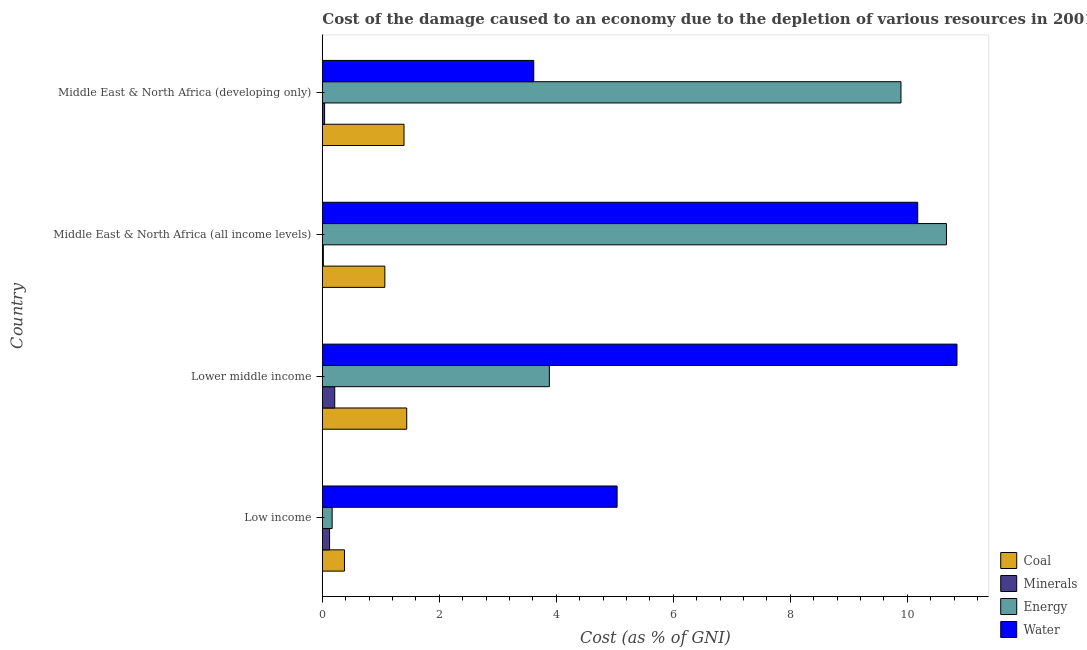How many different coloured bars are there?
Your answer should be very brief. 4. How many groups of bars are there?
Keep it short and to the point. 4. Are the number of bars per tick equal to the number of legend labels?
Provide a succinct answer. Yes. How many bars are there on the 4th tick from the bottom?
Offer a terse response. 4. What is the label of the 4th group of bars from the top?
Offer a terse response. Low income. What is the cost of damage due to depletion of energy in Lower middle income?
Keep it short and to the point. 3.88. Across all countries, what is the maximum cost of damage due to depletion of water?
Your response must be concise. 10.85. Across all countries, what is the minimum cost of damage due to depletion of minerals?
Provide a succinct answer. 0.02. In which country was the cost of damage due to depletion of minerals maximum?
Make the answer very short. Lower middle income. In which country was the cost of damage due to depletion of minerals minimum?
Provide a succinct answer. Middle East & North Africa (all income levels). What is the total cost of damage due to depletion of water in the graph?
Keep it short and to the point. 29.69. What is the difference between the cost of damage due to depletion of coal in Low income and that in Middle East & North Africa (all income levels)?
Your answer should be compact. -0.69. What is the difference between the cost of damage due to depletion of coal in Lower middle income and the cost of damage due to depletion of minerals in Low income?
Offer a very short reply. 1.32. What is the average cost of damage due to depletion of coal per country?
Ensure brevity in your answer.  1.07. What is the difference between the cost of damage due to depletion of minerals and cost of damage due to depletion of water in Middle East & North Africa (all income levels)?
Provide a short and direct response. -10.16. In how many countries, is the cost of damage due to depletion of minerals greater than 5.6 %?
Make the answer very short. 0. What is the ratio of the cost of damage due to depletion of coal in Middle East & North Africa (all income levels) to that in Middle East & North Africa (developing only)?
Offer a terse response. 0.77. Is the difference between the cost of damage due to depletion of coal in Middle East & North Africa (all income levels) and Middle East & North Africa (developing only) greater than the difference between the cost of damage due to depletion of energy in Middle East & North Africa (all income levels) and Middle East & North Africa (developing only)?
Provide a succinct answer. No. What is the difference between the highest and the second highest cost of damage due to depletion of water?
Provide a short and direct response. 0.67. What is the difference between the highest and the lowest cost of damage due to depletion of minerals?
Give a very brief answer. 0.19. In how many countries, is the cost of damage due to depletion of minerals greater than the average cost of damage due to depletion of minerals taken over all countries?
Provide a succinct answer. 2. Is it the case that in every country, the sum of the cost of damage due to depletion of water and cost of damage due to depletion of minerals is greater than the sum of cost of damage due to depletion of energy and cost of damage due to depletion of coal?
Keep it short and to the point. No. What does the 3rd bar from the top in Middle East & North Africa (developing only) represents?
Make the answer very short. Minerals. What does the 3rd bar from the bottom in Lower middle income represents?
Your answer should be very brief. Energy. How many bars are there?
Offer a very short reply. 16. Are all the bars in the graph horizontal?
Provide a succinct answer. Yes. How many countries are there in the graph?
Offer a very short reply. 4. Are the values on the major ticks of X-axis written in scientific E-notation?
Give a very brief answer. No. Does the graph contain any zero values?
Offer a terse response. No. Does the graph contain grids?
Give a very brief answer. No. What is the title of the graph?
Offer a terse response. Cost of the damage caused to an economy due to the depletion of various resources in 2001 . Does "Payroll services" appear as one of the legend labels in the graph?
Ensure brevity in your answer.  No. What is the label or title of the X-axis?
Your response must be concise. Cost (as % of GNI). What is the Cost (as % of GNI) in Coal in Low income?
Give a very brief answer. 0.38. What is the Cost (as % of GNI) in Minerals in Low income?
Offer a very short reply. 0.12. What is the Cost (as % of GNI) of Energy in Low income?
Your answer should be compact. 0.17. What is the Cost (as % of GNI) in Water in Low income?
Ensure brevity in your answer.  5.04. What is the Cost (as % of GNI) in Coal in Lower middle income?
Provide a short and direct response. 1.44. What is the Cost (as % of GNI) of Minerals in Lower middle income?
Give a very brief answer. 0.21. What is the Cost (as % of GNI) of Energy in Lower middle income?
Make the answer very short. 3.88. What is the Cost (as % of GNI) of Water in Lower middle income?
Give a very brief answer. 10.85. What is the Cost (as % of GNI) in Coal in Middle East & North Africa (all income levels)?
Keep it short and to the point. 1.07. What is the Cost (as % of GNI) in Minerals in Middle East & North Africa (all income levels)?
Provide a short and direct response. 0.02. What is the Cost (as % of GNI) of Energy in Middle East & North Africa (all income levels)?
Provide a short and direct response. 10.67. What is the Cost (as % of GNI) of Water in Middle East & North Africa (all income levels)?
Your response must be concise. 10.18. What is the Cost (as % of GNI) of Coal in Middle East & North Africa (developing only)?
Your answer should be compact. 1.4. What is the Cost (as % of GNI) of Minerals in Middle East & North Africa (developing only)?
Make the answer very short. 0.04. What is the Cost (as % of GNI) of Energy in Middle East & North Africa (developing only)?
Your answer should be compact. 9.89. What is the Cost (as % of GNI) in Water in Middle East & North Africa (developing only)?
Offer a terse response. 3.61. Across all countries, what is the maximum Cost (as % of GNI) of Coal?
Your answer should be very brief. 1.44. Across all countries, what is the maximum Cost (as % of GNI) of Minerals?
Give a very brief answer. 0.21. Across all countries, what is the maximum Cost (as % of GNI) in Energy?
Your answer should be compact. 10.67. Across all countries, what is the maximum Cost (as % of GNI) in Water?
Your answer should be compact. 10.85. Across all countries, what is the minimum Cost (as % of GNI) of Coal?
Give a very brief answer. 0.38. Across all countries, what is the minimum Cost (as % of GNI) in Minerals?
Give a very brief answer. 0.02. Across all countries, what is the minimum Cost (as % of GNI) in Energy?
Provide a short and direct response. 0.17. Across all countries, what is the minimum Cost (as % of GNI) of Water?
Provide a succinct answer. 3.61. What is the total Cost (as % of GNI) of Coal in the graph?
Offer a terse response. 4.29. What is the total Cost (as % of GNI) in Minerals in the graph?
Ensure brevity in your answer.  0.39. What is the total Cost (as % of GNI) in Energy in the graph?
Your answer should be very brief. 24.61. What is the total Cost (as % of GNI) of Water in the graph?
Provide a short and direct response. 29.69. What is the difference between the Cost (as % of GNI) of Coal in Low income and that in Lower middle income?
Your answer should be compact. -1.06. What is the difference between the Cost (as % of GNI) in Minerals in Low income and that in Lower middle income?
Provide a short and direct response. -0.09. What is the difference between the Cost (as % of GNI) of Energy in Low income and that in Lower middle income?
Offer a very short reply. -3.71. What is the difference between the Cost (as % of GNI) of Water in Low income and that in Lower middle income?
Keep it short and to the point. -5.81. What is the difference between the Cost (as % of GNI) of Coal in Low income and that in Middle East & North Africa (all income levels)?
Give a very brief answer. -0.69. What is the difference between the Cost (as % of GNI) of Minerals in Low income and that in Middle East & North Africa (all income levels)?
Offer a very short reply. 0.11. What is the difference between the Cost (as % of GNI) of Energy in Low income and that in Middle East & North Africa (all income levels)?
Keep it short and to the point. -10.5. What is the difference between the Cost (as % of GNI) of Water in Low income and that in Middle East & North Africa (all income levels)?
Make the answer very short. -5.14. What is the difference between the Cost (as % of GNI) of Coal in Low income and that in Middle East & North Africa (developing only)?
Provide a succinct answer. -1.02. What is the difference between the Cost (as % of GNI) of Minerals in Low income and that in Middle East & North Africa (developing only)?
Make the answer very short. 0.08. What is the difference between the Cost (as % of GNI) of Energy in Low income and that in Middle East & North Africa (developing only)?
Your response must be concise. -9.73. What is the difference between the Cost (as % of GNI) of Water in Low income and that in Middle East & North Africa (developing only)?
Give a very brief answer. 1.43. What is the difference between the Cost (as % of GNI) of Coal in Lower middle income and that in Middle East & North Africa (all income levels)?
Offer a very short reply. 0.37. What is the difference between the Cost (as % of GNI) of Minerals in Lower middle income and that in Middle East & North Africa (all income levels)?
Make the answer very short. 0.19. What is the difference between the Cost (as % of GNI) of Energy in Lower middle income and that in Middle East & North Africa (all income levels)?
Offer a terse response. -6.79. What is the difference between the Cost (as % of GNI) in Water in Lower middle income and that in Middle East & North Africa (all income levels)?
Offer a terse response. 0.67. What is the difference between the Cost (as % of GNI) of Coal in Lower middle income and that in Middle East & North Africa (developing only)?
Your answer should be very brief. 0.05. What is the difference between the Cost (as % of GNI) in Minerals in Lower middle income and that in Middle East & North Africa (developing only)?
Offer a terse response. 0.17. What is the difference between the Cost (as % of GNI) of Energy in Lower middle income and that in Middle East & North Africa (developing only)?
Your answer should be very brief. -6.01. What is the difference between the Cost (as % of GNI) in Water in Lower middle income and that in Middle East & North Africa (developing only)?
Your answer should be very brief. 7.24. What is the difference between the Cost (as % of GNI) in Coal in Middle East & North Africa (all income levels) and that in Middle East & North Africa (developing only)?
Provide a succinct answer. -0.33. What is the difference between the Cost (as % of GNI) of Minerals in Middle East & North Africa (all income levels) and that in Middle East & North Africa (developing only)?
Your response must be concise. -0.02. What is the difference between the Cost (as % of GNI) in Energy in Middle East & North Africa (all income levels) and that in Middle East & North Africa (developing only)?
Keep it short and to the point. 0.78. What is the difference between the Cost (as % of GNI) of Water in Middle East & North Africa (all income levels) and that in Middle East & North Africa (developing only)?
Keep it short and to the point. 6.57. What is the difference between the Cost (as % of GNI) of Coal in Low income and the Cost (as % of GNI) of Minerals in Lower middle income?
Your answer should be very brief. 0.17. What is the difference between the Cost (as % of GNI) of Coal in Low income and the Cost (as % of GNI) of Energy in Lower middle income?
Your response must be concise. -3.5. What is the difference between the Cost (as % of GNI) in Coal in Low income and the Cost (as % of GNI) in Water in Lower middle income?
Ensure brevity in your answer.  -10.47. What is the difference between the Cost (as % of GNI) of Minerals in Low income and the Cost (as % of GNI) of Energy in Lower middle income?
Your response must be concise. -3.76. What is the difference between the Cost (as % of GNI) in Minerals in Low income and the Cost (as % of GNI) in Water in Lower middle income?
Ensure brevity in your answer.  -10.73. What is the difference between the Cost (as % of GNI) of Energy in Low income and the Cost (as % of GNI) of Water in Lower middle income?
Provide a succinct answer. -10.68. What is the difference between the Cost (as % of GNI) in Coal in Low income and the Cost (as % of GNI) in Minerals in Middle East & North Africa (all income levels)?
Offer a very short reply. 0.36. What is the difference between the Cost (as % of GNI) of Coal in Low income and the Cost (as % of GNI) of Energy in Middle East & North Africa (all income levels)?
Give a very brief answer. -10.29. What is the difference between the Cost (as % of GNI) of Coal in Low income and the Cost (as % of GNI) of Water in Middle East & North Africa (all income levels)?
Offer a terse response. -9.8. What is the difference between the Cost (as % of GNI) in Minerals in Low income and the Cost (as % of GNI) in Energy in Middle East & North Africa (all income levels)?
Provide a succinct answer. -10.55. What is the difference between the Cost (as % of GNI) in Minerals in Low income and the Cost (as % of GNI) in Water in Middle East & North Africa (all income levels)?
Your answer should be very brief. -10.06. What is the difference between the Cost (as % of GNI) in Energy in Low income and the Cost (as % of GNI) in Water in Middle East & North Africa (all income levels)?
Keep it short and to the point. -10.01. What is the difference between the Cost (as % of GNI) in Coal in Low income and the Cost (as % of GNI) in Minerals in Middle East & North Africa (developing only)?
Give a very brief answer. 0.34. What is the difference between the Cost (as % of GNI) of Coal in Low income and the Cost (as % of GNI) of Energy in Middle East & North Africa (developing only)?
Provide a short and direct response. -9.52. What is the difference between the Cost (as % of GNI) in Coal in Low income and the Cost (as % of GNI) in Water in Middle East & North Africa (developing only)?
Offer a very short reply. -3.24. What is the difference between the Cost (as % of GNI) in Minerals in Low income and the Cost (as % of GNI) in Energy in Middle East & North Africa (developing only)?
Offer a terse response. -9.77. What is the difference between the Cost (as % of GNI) in Minerals in Low income and the Cost (as % of GNI) in Water in Middle East & North Africa (developing only)?
Make the answer very short. -3.49. What is the difference between the Cost (as % of GNI) of Energy in Low income and the Cost (as % of GNI) of Water in Middle East & North Africa (developing only)?
Provide a succinct answer. -3.45. What is the difference between the Cost (as % of GNI) in Coal in Lower middle income and the Cost (as % of GNI) in Minerals in Middle East & North Africa (all income levels)?
Your response must be concise. 1.43. What is the difference between the Cost (as % of GNI) in Coal in Lower middle income and the Cost (as % of GNI) in Energy in Middle East & North Africa (all income levels)?
Offer a terse response. -9.23. What is the difference between the Cost (as % of GNI) in Coal in Lower middle income and the Cost (as % of GNI) in Water in Middle East & North Africa (all income levels)?
Your answer should be compact. -8.74. What is the difference between the Cost (as % of GNI) in Minerals in Lower middle income and the Cost (as % of GNI) in Energy in Middle East & North Africa (all income levels)?
Provide a short and direct response. -10.46. What is the difference between the Cost (as % of GNI) in Minerals in Lower middle income and the Cost (as % of GNI) in Water in Middle East & North Africa (all income levels)?
Keep it short and to the point. -9.97. What is the difference between the Cost (as % of GNI) in Energy in Lower middle income and the Cost (as % of GNI) in Water in Middle East & North Africa (all income levels)?
Give a very brief answer. -6.3. What is the difference between the Cost (as % of GNI) of Coal in Lower middle income and the Cost (as % of GNI) of Minerals in Middle East & North Africa (developing only)?
Provide a succinct answer. 1.4. What is the difference between the Cost (as % of GNI) in Coal in Lower middle income and the Cost (as % of GNI) in Energy in Middle East & North Africa (developing only)?
Ensure brevity in your answer.  -8.45. What is the difference between the Cost (as % of GNI) in Coal in Lower middle income and the Cost (as % of GNI) in Water in Middle East & North Africa (developing only)?
Give a very brief answer. -2.17. What is the difference between the Cost (as % of GNI) of Minerals in Lower middle income and the Cost (as % of GNI) of Energy in Middle East & North Africa (developing only)?
Give a very brief answer. -9.68. What is the difference between the Cost (as % of GNI) in Minerals in Lower middle income and the Cost (as % of GNI) in Water in Middle East & North Africa (developing only)?
Your answer should be compact. -3.4. What is the difference between the Cost (as % of GNI) of Energy in Lower middle income and the Cost (as % of GNI) of Water in Middle East & North Africa (developing only)?
Provide a succinct answer. 0.27. What is the difference between the Cost (as % of GNI) in Coal in Middle East & North Africa (all income levels) and the Cost (as % of GNI) in Minerals in Middle East & North Africa (developing only)?
Your answer should be very brief. 1.03. What is the difference between the Cost (as % of GNI) of Coal in Middle East & North Africa (all income levels) and the Cost (as % of GNI) of Energy in Middle East & North Africa (developing only)?
Ensure brevity in your answer.  -8.82. What is the difference between the Cost (as % of GNI) in Coal in Middle East & North Africa (all income levels) and the Cost (as % of GNI) in Water in Middle East & North Africa (developing only)?
Provide a succinct answer. -2.55. What is the difference between the Cost (as % of GNI) in Minerals in Middle East & North Africa (all income levels) and the Cost (as % of GNI) in Energy in Middle East & North Africa (developing only)?
Provide a short and direct response. -9.88. What is the difference between the Cost (as % of GNI) in Minerals in Middle East & North Africa (all income levels) and the Cost (as % of GNI) in Water in Middle East & North Africa (developing only)?
Offer a terse response. -3.6. What is the difference between the Cost (as % of GNI) of Energy in Middle East & North Africa (all income levels) and the Cost (as % of GNI) of Water in Middle East & North Africa (developing only)?
Your answer should be very brief. 7.06. What is the average Cost (as % of GNI) of Coal per country?
Provide a short and direct response. 1.07. What is the average Cost (as % of GNI) in Minerals per country?
Your answer should be compact. 0.1. What is the average Cost (as % of GNI) in Energy per country?
Ensure brevity in your answer.  6.15. What is the average Cost (as % of GNI) in Water per country?
Your answer should be very brief. 7.42. What is the difference between the Cost (as % of GNI) of Coal and Cost (as % of GNI) of Minerals in Low income?
Make the answer very short. 0.25. What is the difference between the Cost (as % of GNI) of Coal and Cost (as % of GNI) of Energy in Low income?
Offer a terse response. 0.21. What is the difference between the Cost (as % of GNI) of Coal and Cost (as % of GNI) of Water in Low income?
Your answer should be very brief. -4.66. What is the difference between the Cost (as % of GNI) of Minerals and Cost (as % of GNI) of Energy in Low income?
Provide a short and direct response. -0.04. What is the difference between the Cost (as % of GNI) in Minerals and Cost (as % of GNI) in Water in Low income?
Offer a very short reply. -4.92. What is the difference between the Cost (as % of GNI) in Energy and Cost (as % of GNI) in Water in Low income?
Offer a very short reply. -4.87. What is the difference between the Cost (as % of GNI) in Coal and Cost (as % of GNI) in Minerals in Lower middle income?
Your response must be concise. 1.23. What is the difference between the Cost (as % of GNI) in Coal and Cost (as % of GNI) in Energy in Lower middle income?
Provide a succinct answer. -2.44. What is the difference between the Cost (as % of GNI) of Coal and Cost (as % of GNI) of Water in Lower middle income?
Offer a terse response. -9.41. What is the difference between the Cost (as % of GNI) of Minerals and Cost (as % of GNI) of Energy in Lower middle income?
Provide a succinct answer. -3.67. What is the difference between the Cost (as % of GNI) in Minerals and Cost (as % of GNI) in Water in Lower middle income?
Offer a very short reply. -10.64. What is the difference between the Cost (as % of GNI) in Energy and Cost (as % of GNI) in Water in Lower middle income?
Your response must be concise. -6.97. What is the difference between the Cost (as % of GNI) in Coal and Cost (as % of GNI) in Minerals in Middle East & North Africa (all income levels)?
Provide a short and direct response. 1.05. What is the difference between the Cost (as % of GNI) in Coal and Cost (as % of GNI) in Energy in Middle East & North Africa (all income levels)?
Make the answer very short. -9.6. What is the difference between the Cost (as % of GNI) of Coal and Cost (as % of GNI) of Water in Middle East & North Africa (all income levels)?
Give a very brief answer. -9.11. What is the difference between the Cost (as % of GNI) in Minerals and Cost (as % of GNI) in Energy in Middle East & North Africa (all income levels)?
Your answer should be very brief. -10.65. What is the difference between the Cost (as % of GNI) of Minerals and Cost (as % of GNI) of Water in Middle East & North Africa (all income levels)?
Offer a very short reply. -10.16. What is the difference between the Cost (as % of GNI) of Energy and Cost (as % of GNI) of Water in Middle East & North Africa (all income levels)?
Your response must be concise. 0.49. What is the difference between the Cost (as % of GNI) in Coal and Cost (as % of GNI) in Minerals in Middle East & North Africa (developing only)?
Offer a very short reply. 1.36. What is the difference between the Cost (as % of GNI) in Coal and Cost (as % of GNI) in Energy in Middle East & North Africa (developing only)?
Your answer should be very brief. -8.5. What is the difference between the Cost (as % of GNI) of Coal and Cost (as % of GNI) of Water in Middle East & North Africa (developing only)?
Your response must be concise. -2.22. What is the difference between the Cost (as % of GNI) of Minerals and Cost (as % of GNI) of Energy in Middle East & North Africa (developing only)?
Make the answer very short. -9.85. What is the difference between the Cost (as % of GNI) of Minerals and Cost (as % of GNI) of Water in Middle East & North Africa (developing only)?
Keep it short and to the point. -3.58. What is the difference between the Cost (as % of GNI) of Energy and Cost (as % of GNI) of Water in Middle East & North Africa (developing only)?
Offer a terse response. 6.28. What is the ratio of the Cost (as % of GNI) in Coal in Low income to that in Lower middle income?
Offer a terse response. 0.26. What is the ratio of the Cost (as % of GNI) in Minerals in Low income to that in Lower middle income?
Ensure brevity in your answer.  0.58. What is the ratio of the Cost (as % of GNI) in Energy in Low income to that in Lower middle income?
Your response must be concise. 0.04. What is the ratio of the Cost (as % of GNI) in Water in Low income to that in Lower middle income?
Ensure brevity in your answer.  0.46. What is the ratio of the Cost (as % of GNI) in Coal in Low income to that in Middle East & North Africa (all income levels)?
Provide a short and direct response. 0.35. What is the ratio of the Cost (as % of GNI) of Minerals in Low income to that in Middle East & North Africa (all income levels)?
Give a very brief answer. 7.14. What is the ratio of the Cost (as % of GNI) in Energy in Low income to that in Middle East & North Africa (all income levels)?
Make the answer very short. 0.02. What is the ratio of the Cost (as % of GNI) in Water in Low income to that in Middle East & North Africa (all income levels)?
Give a very brief answer. 0.5. What is the ratio of the Cost (as % of GNI) in Coal in Low income to that in Middle East & North Africa (developing only)?
Provide a short and direct response. 0.27. What is the ratio of the Cost (as % of GNI) in Minerals in Low income to that in Middle East & North Africa (developing only)?
Give a very brief answer. 3.18. What is the ratio of the Cost (as % of GNI) in Energy in Low income to that in Middle East & North Africa (developing only)?
Give a very brief answer. 0.02. What is the ratio of the Cost (as % of GNI) of Water in Low income to that in Middle East & North Africa (developing only)?
Offer a terse response. 1.39. What is the ratio of the Cost (as % of GNI) in Coal in Lower middle income to that in Middle East & North Africa (all income levels)?
Make the answer very short. 1.35. What is the ratio of the Cost (as % of GNI) in Minerals in Lower middle income to that in Middle East & North Africa (all income levels)?
Provide a succinct answer. 12.24. What is the ratio of the Cost (as % of GNI) in Energy in Lower middle income to that in Middle East & North Africa (all income levels)?
Your answer should be compact. 0.36. What is the ratio of the Cost (as % of GNI) of Water in Lower middle income to that in Middle East & North Africa (all income levels)?
Keep it short and to the point. 1.07. What is the ratio of the Cost (as % of GNI) of Coal in Lower middle income to that in Middle East & North Africa (developing only)?
Your answer should be compact. 1.03. What is the ratio of the Cost (as % of GNI) in Minerals in Lower middle income to that in Middle East & North Africa (developing only)?
Make the answer very short. 5.46. What is the ratio of the Cost (as % of GNI) in Energy in Lower middle income to that in Middle East & North Africa (developing only)?
Give a very brief answer. 0.39. What is the ratio of the Cost (as % of GNI) of Water in Lower middle income to that in Middle East & North Africa (developing only)?
Keep it short and to the point. 3. What is the ratio of the Cost (as % of GNI) in Coal in Middle East & North Africa (all income levels) to that in Middle East & North Africa (developing only)?
Keep it short and to the point. 0.77. What is the ratio of the Cost (as % of GNI) in Minerals in Middle East & North Africa (all income levels) to that in Middle East & North Africa (developing only)?
Offer a terse response. 0.45. What is the ratio of the Cost (as % of GNI) of Energy in Middle East & North Africa (all income levels) to that in Middle East & North Africa (developing only)?
Offer a terse response. 1.08. What is the ratio of the Cost (as % of GNI) of Water in Middle East & North Africa (all income levels) to that in Middle East & North Africa (developing only)?
Your response must be concise. 2.82. What is the difference between the highest and the second highest Cost (as % of GNI) of Coal?
Your answer should be compact. 0.05. What is the difference between the highest and the second highest Cost (as % of GNI) in Minerals?
Offer a very short reply. 0.09. What is the difference between the highest and the second highest Cost (as % of GNI) of Energy?
Offer a terse response. 0.78. What is the difference between the highest and the second highest Cost (as % of GNI) of Water?
Make the answer very short. 0.67. What is the difference between the highest and the lowest Cost (as % of GNI) of Coal?
Give a very brief answer. 1.06. What is the difference between the highest and the lowest Cost (as % of GNI) in Minerals?
Give a very brief answer. 0.19. What is the difference between the highest and the lowest Cost (as % of GNI) in Energy?
Your response must be concise. 10.5. What is the difference between the highest and the lowest Cost (as % of GNI) of Water?
Your answer should be very brief. 7.24. 